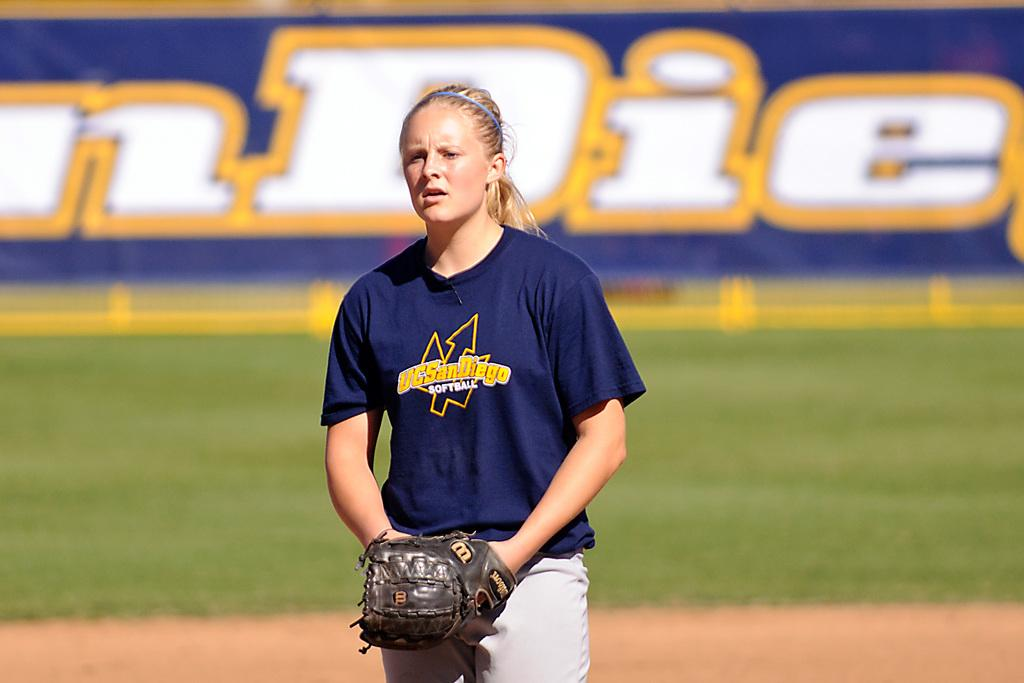Who is the main subject in the image? There is a woman in the image. What is the woman wearing on her hand? The woman is wearing a glove. What is the woman's posture in the image? The woman is standing. What can be seen in the background of the image? There is grass and a poster in the background of the image. How would you describe the background's appearance? The background appears blurry. What type of cake is being processed in the image? There is no cake or process present in the image; it features a woman standing with a blurry background. Can you see any rays of light in the image? There are no rays of light visible in the image. 